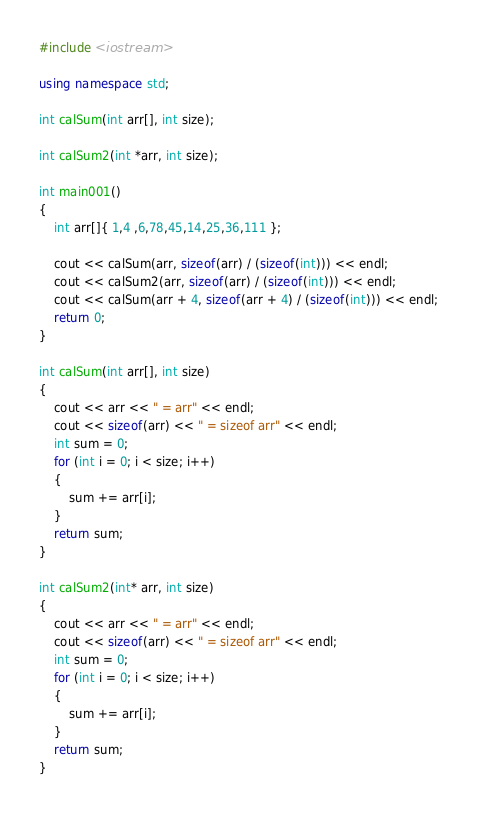<code> <loc_0><loc_0><loc_500><loc_500><_C++_>#include <iostream>

using namespace std;

int calSum(int arr[], int size);

int calSum2(int *arr, int size);

int main001()
{
    int arr[]{ 1,4 ,6,78,45,14,25,36,111 };

    cout << calSum(arr, sizeof(arr) / (sizeof(int))) << endl;
    cout << calSum2(arr, sizeof(arr) / (sizeof(int))) << endl;
    cout << calSum(arr + 4, sizeof(arr + 4) / (sizeof(int))) << endl;
    return 0;
}

int calSum(int arr[], int size)
{
    cout << arr << " = arr" << endl;
    cout << sizeof(arr) << " = sizeof arr" << endl;
    int sum = 0;
    for (int i = 0; i < size; i++)
    {
        sum += arr[i];
    }
    return sum;
}

int calSum2(int* arr, int size)
{
    cout << arr << " = arr" << endl;
    cout << sizeof(arr) << " = sizeof arr" << endl;
    int sum = 0;
    for (int i = 0; i < size; i++)
    {
        sum += arr[i];
    }
    return sum;
}
</code> 